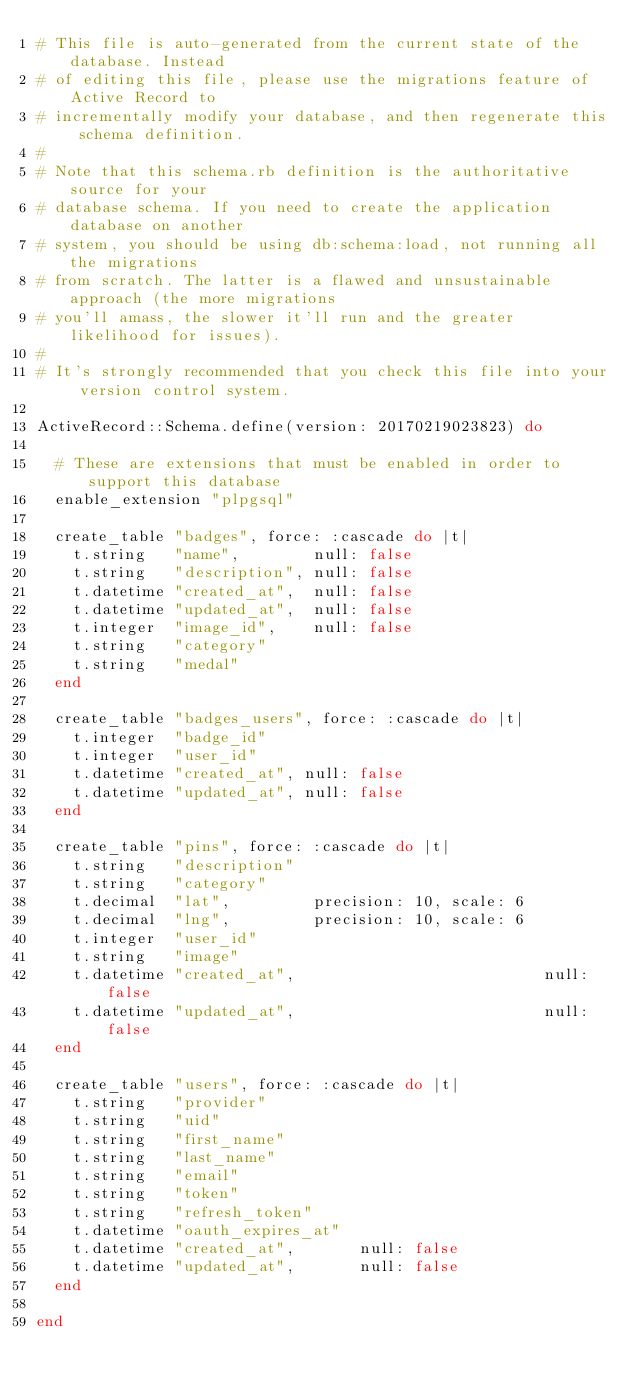<code> <loc_0><loc_0><loc_500><loc_500><_Ruby_># This file is auto-generated from the current state of the database. Instead
# of editing this file, please use the migrations feature of Active Record to
# incrementally modify your database, and then regenerate this schema definition.
#
# Note that this schema.rb definition is the authoritative source for your
# database schema. If you need to create the application database on another
# system, you should be using db:schema:load, not running all the migrations
# from scratch. The latter is a flawed and unsustainable approach (the more migrations
# you'll amass, the slower it'll run and the greater likelihood for issues).
#
# It's strongly recommended that you check this file into your version control system.

ActiveRecord::Schema.define(version: 20170219023823) do

  # These are extensions that must be enabled in order to support this database
  enable_extension "plpgsql"

  create_table "badges", force: :cascade do |t|
    t.string   "name",        null: false
    t.string   "description", null: false
    t.datetime "created_at",  null: false
    t.datetime "updated_at",  null: false
    t.integer  "image_id",    null: false
    t.string   "category"
    t.string   "medal"
  end

  create_table "badges_users", force: :cascade do |t|
    t.integer  "badge_id"
    t.integer  "user_id"
    t.datetime "created_at", null: false
    t.datetime "updated_at", null: false
  end

  create_table "pins", force: :cascade do |t|
    t.string   "description"
    t.string   "category"
    t.decimal  "lat",         precision: 10, scale: 6
    t.decimal  "lng",         precision: 10, scale: 6
    t.integer  "user_id"
    t.string   "image"
    t.datetime "created_at",                           null: false
    t.datetime "updated_at",                           null: false
  end

  create_table "users", force: :cascade do |t|
    t.string   "provider"
    t.string   "uid"
    t.string   "first_name"
    t.string   "last_name"
    t.string   "email"
    t.string   "token"
    t.string   "refresh_token"
    t.datetime "oauth_expires_at"
    t.datetime "created_at",       null: false
    t.datetime "updated_at",       null: false
  end

end
</code> 